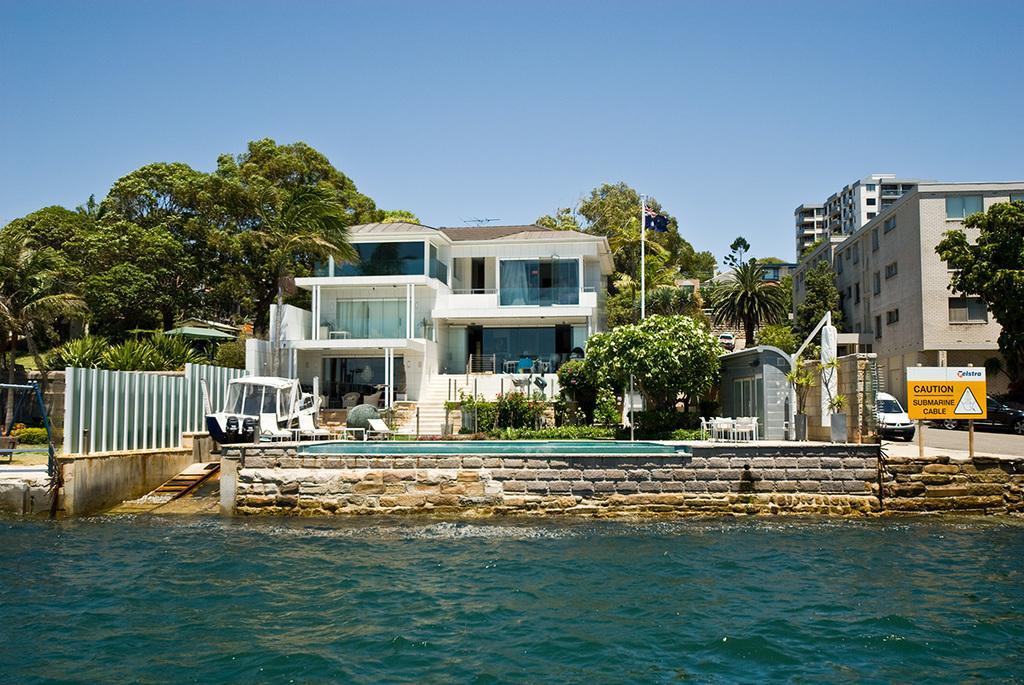Could you give a brief overview of what you see in this image? In this image, there are a few buildings. We can see some chairs and tables. We can see some grass, plants and trees. We can see some stairs. We can see a white colored object. We can see the fence. We can see some water. We can see a few vehicles. We can see a board with some text and image. We can see an umbrella, a flag. We can see the sky. We can see the wall. 